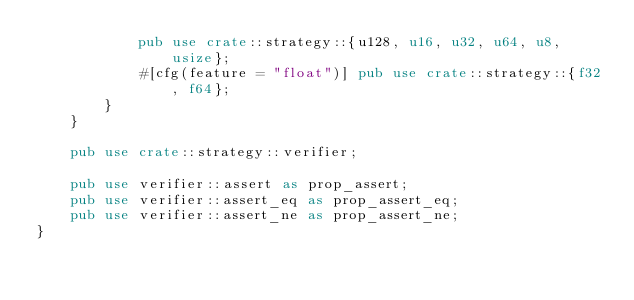<code> <loc_0><loc_0><loc_500><loc_500><_Rust_>            pub use crate::strategy::{u128, u16, u32, u64, u8, usize};
            #[cfg(feature = "float")] pub use crate::strategy::{f32, f64};
        }
    }

    pub use crate::strategy::verifier;

    pub use verifier::assert as prop_assert;
    pub use verifier::assert_eq as prop_assert_eq;
    pub use verifier::assert_ne as prop_assert_ne;
}
</code> 